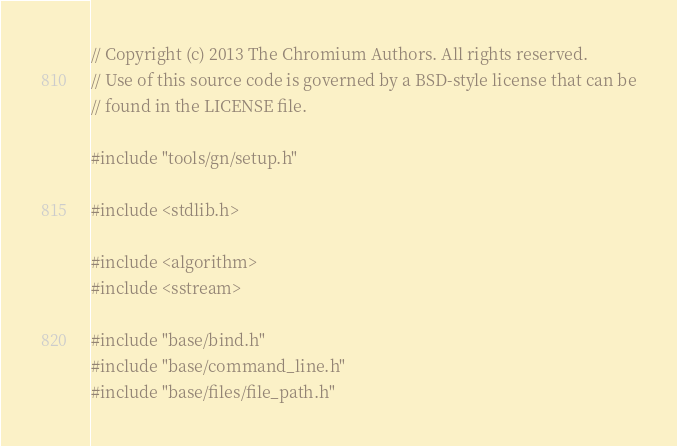<code> <loc_0><loc_0><loc_500><loc_500><_C++_>// Copyright (c) 2013 The Chromium Authors. All rights reserved.
// Use of this source code is governed by a BSD-style license that can be
// found in the LICENSE file.

#include "tools/gn/setup.h"

#include <stdlib.h>

#include <algorithm>
#include <sstream>

#include "base/bind.h"
#include "base/command_line.h"
#include "base/files/file_path.h"</code> 